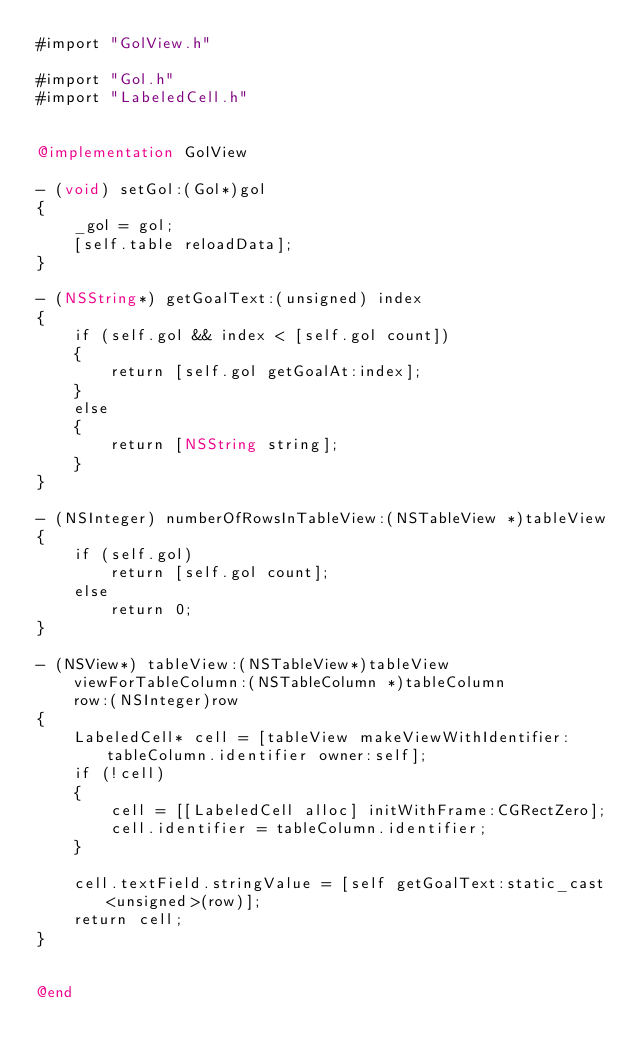Convert code to text. <code><loc_0><loc_0><loc_500><loc_500><_ObjectiveC_>#import "GolView.h"

#import "Gol.h"
#import "LabeledCell.h"


@implementation GolView

- (void) setGol:(Gol*)gol
{
    _gol = gol;
    [self.table reloadData];
}

- (NSString*) getGoalText:(unsigned) index
{
    if (self.gol && index < [self.gol count])
    {
        return [self.gol getGoalAt:index];
    }
    else
    {
        return [NSString string];
    }
}

- (NSInteger) numberOfRowsInTableView:(NSTableView *)tableView
{
    if (self.gol)
        return [self.gol count];
    else
        return 0;
}

- (NSView*) tableView:(NSTableView*)tableView
    viewForTableColumn:(NSTableColumn *)tableColumn
    row:(NSInteger)row
{
    LabeledCell* cell = [tableView makeViewWithIdentifier:tableColumn.identifier owner:self];
    if (!cell)
    {
        cell = [[LabeledCell alloc] initWithFrame:CGRectZero];
        cell.identifier = tableColumn.identifier;
    }

    cell.textField.stringValue = [self getGoalText:static_cast<unsigned>(row)];
    return cell;
}


@end
</code> 